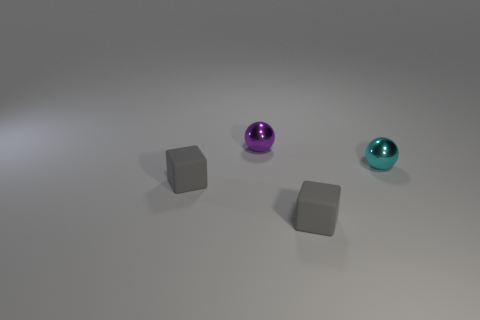Add 3 purple metallic things. How many objects exist? 7 Subtract 0 green balls. How many objects are left? 4 Subtract all metallic spheres. Subtract all green cubes. How many objects are left? 2 Add 2 shiny objects. How many shiny objects are left? 4 Add 4 small shiny things. How many small shiny things exist? 6 